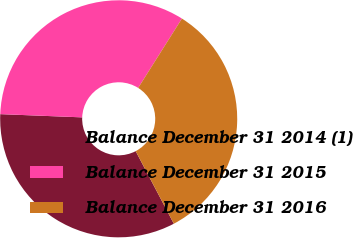<chart> <loc_0><loc_0><loc_500><loc_500><pie_chart><fcel>Balance December 31 2014 (1)<fcel>Balance December 31 2015<fcel>Balance December 31 2016<nl><fcel>33.33%<fcel>33.33%<fcel>33.34%<nl></chart> 